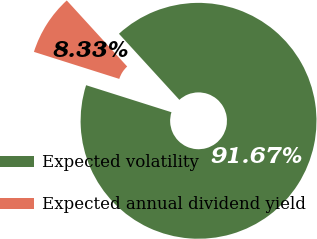Convert chart to OTSL. <chart><loc_0><loc_0><loc_500><loc_500><pie_chart><fcel>Expected volatility<fcel>Expected annual dividend yield<nl><fcel>91.67%<fcel>8.33%<nl></chart> 